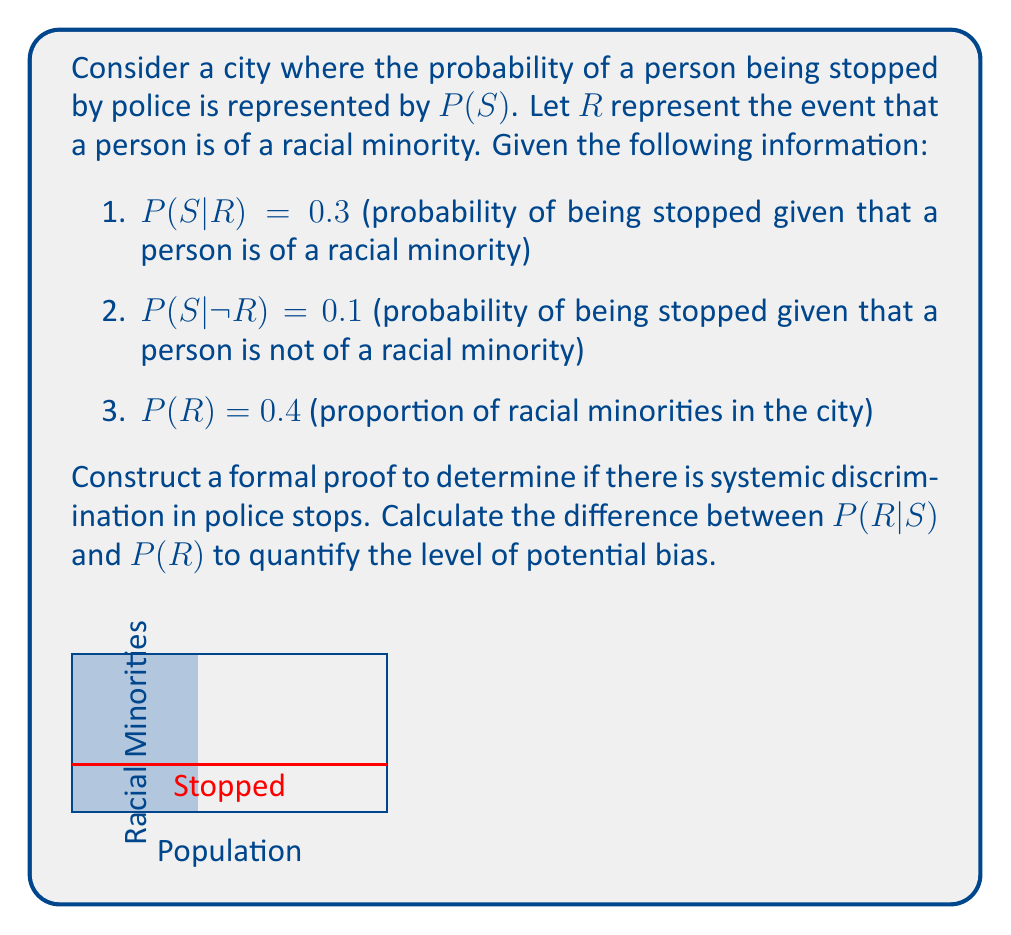Give your solution to this math problem. To prove if there is systemic discrimination, we need to compare the proportion of racial minorities in the general population to the proportion of racial minorities among those stopped by police. We'll use Bayes' Theorem to calculate $P(R|S)$.

Step 1: Calculate $P(S)$ using the law of total probability:
$P(S) = P(S|R)P(R) + P(S|\neg R)P(\neg R)$
$P(S) = 0.3 \cdot 0.4 + 0.1 \cdot 0.6 = 0.12 + 0.06 = 0.18$

Step 2: Apply Bayes' Theorem to find $P(R|S)$:
$P(R|S) = \frac{P(S|R)P(R)}{P(S)} = \frac{0.3 \cdot 0.4}{0.18} = \frac{0.12}{0.18} = \frac{2}{3} \approx 0.6667$

Step 3: Calculate the difference between $P(R|S)$ and $P(R)$:
$P(R|S) - P(R) = 0.6667 - 0.4 = 0.2667$

This positive difference indicates that racial minorities are overrepresented in police stops compared to their proportion in the general population, suggesting systemic discrimination.

To quantify the level of bias, we can express this difference as a percentage increase:
$\frac{0.2667}{0.4} \cdot 100\% = 66.67\%$

This means that racial minorities are about 66.67% more likely to be stopped by police than would be expected based on their representation in the population.
Answer: $P(R|S) - P(R) = 0.2667$, indicating systemic discrimination with a 66.67% increased likelihood of minorities being stopped. 